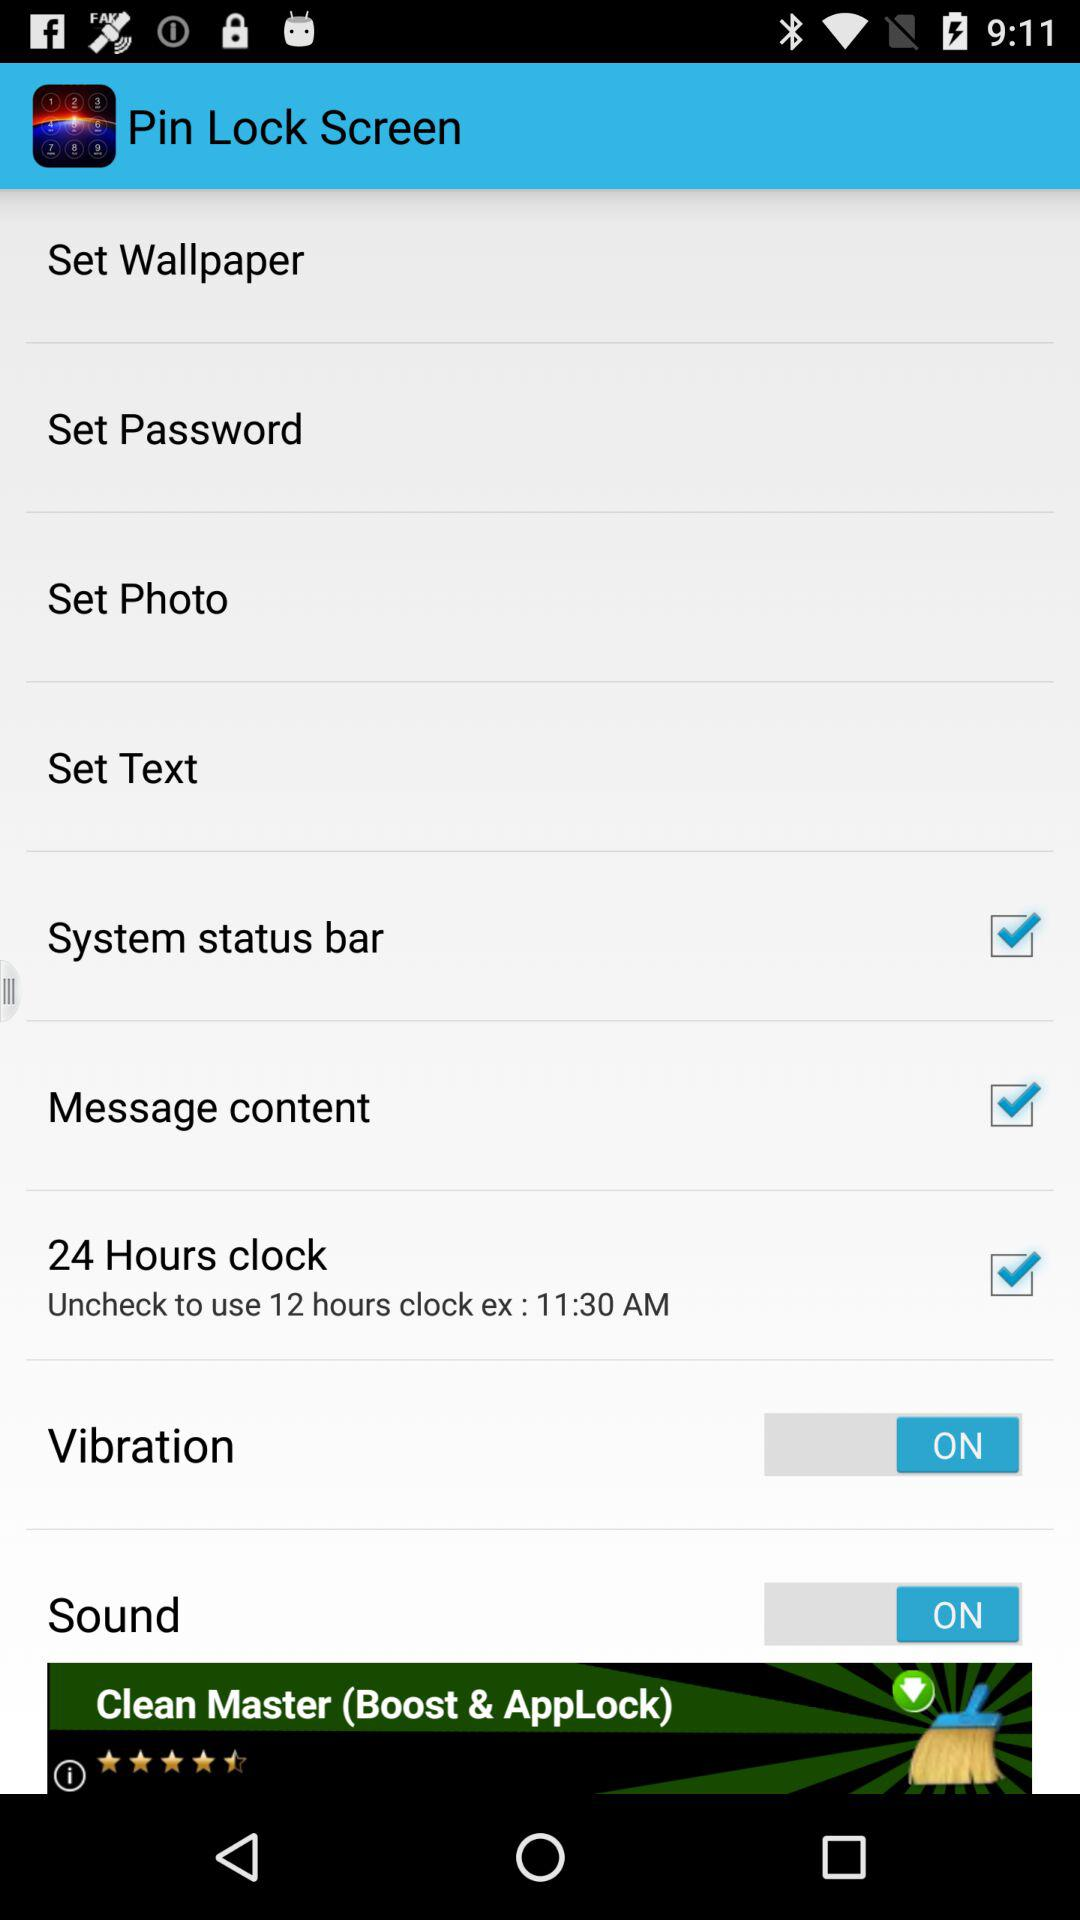Which settings are checked? The checked settings are "System status bar", "Message content" and "24 Hours clock". 